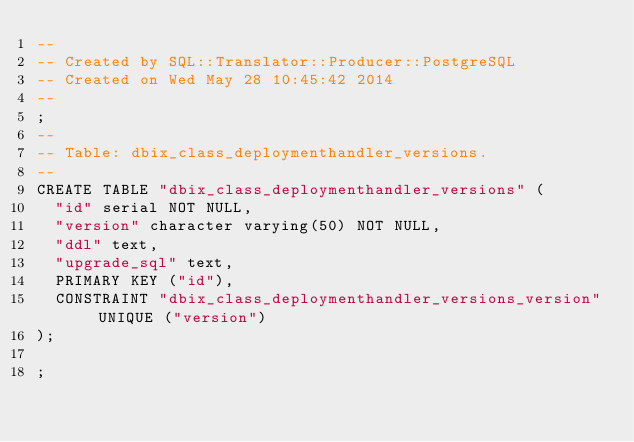Convert code to text. <code><loc_0><loc_0><loc_500><loc_500><_SQL_>-- 
-- Created by SQL::Translator::Producer::PostgreSQL
-- Created on Wed May 28 10:45:42 2014
-- 
;
--
-- Table: dbix_class_deploymenthandler_versions.
--
CREATE TABLE "dbix_class_deploymenthandler_versions" (
  "id" serial NOT NULL,
  "version" character varying(50) NOT NULL,
  "ddl" text,
  "upgrade_sql" text,
  PRIMARY KEY ("id"),
  CONSTRAINT "dbix_class_deploymenthandler_versions_version" UNIQUE ("version")
);

;
</code> 